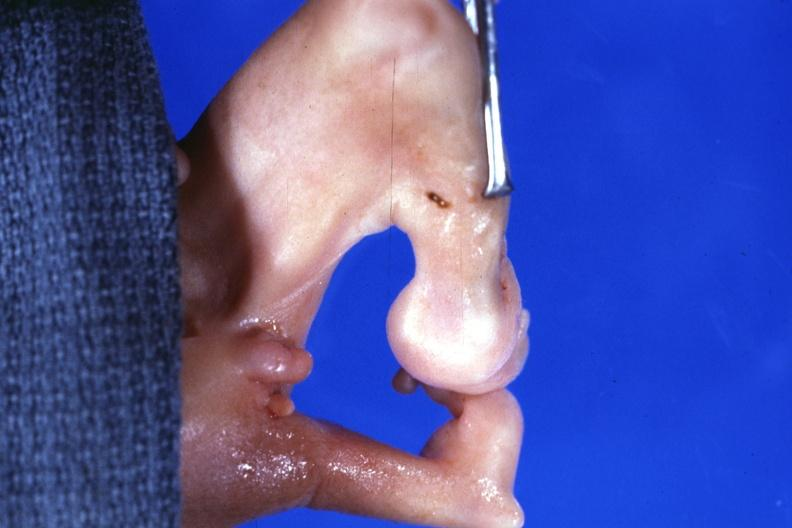what is present?
Answer the question using a single word or phrase. Dysplastic 